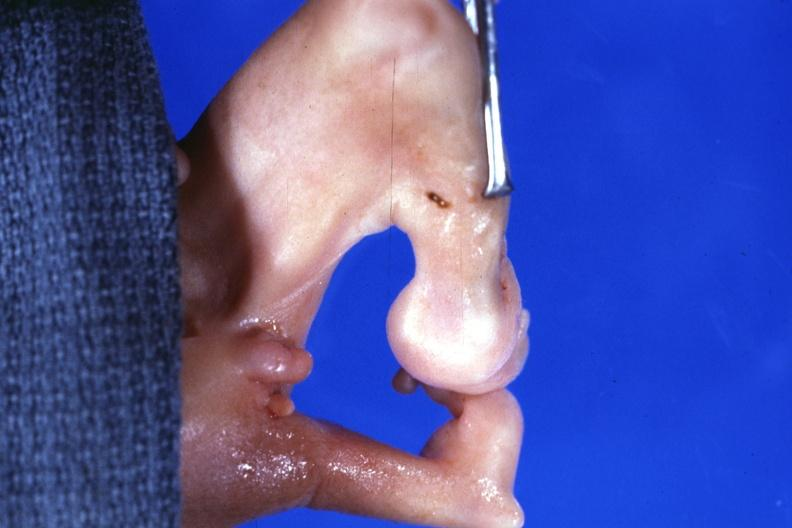what is present?
Answer the question using a single word or phrase. Dysplastic 